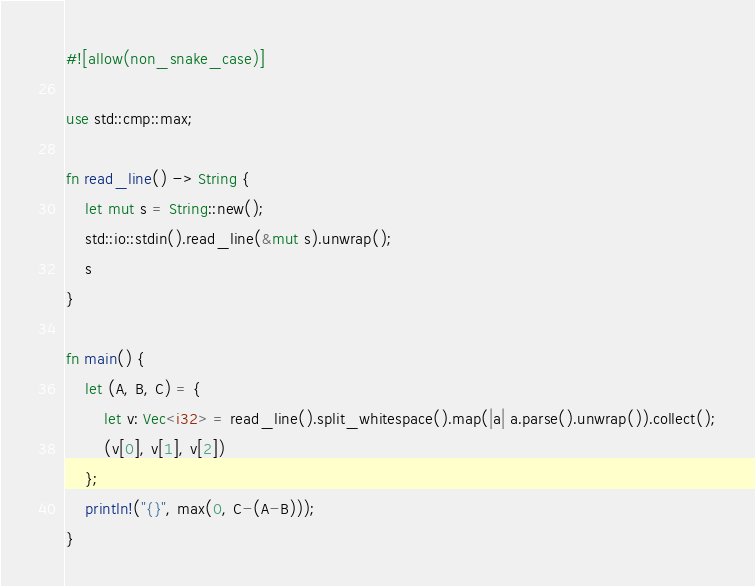Convert code to text. <code><loc_0><loc_0><loc_500><loc_500><_Rust_>#![allow(non_snake_case)]

use std::cmp::max;

fn read_line() -> String {
    let mut s = String::new();
    std::io::stdin().read_line(&mut s).unwrap();
    s
}

fn main() {
    let (A, B, C) = {
        let v: Vec<i32> = read_line().split_whitespace().map(|a| a.parse().unwrap()).collect();
        (v[0], v[1], v[2])
    };
    println!("{}", max(0, C-(A-B)));
}
</code> 